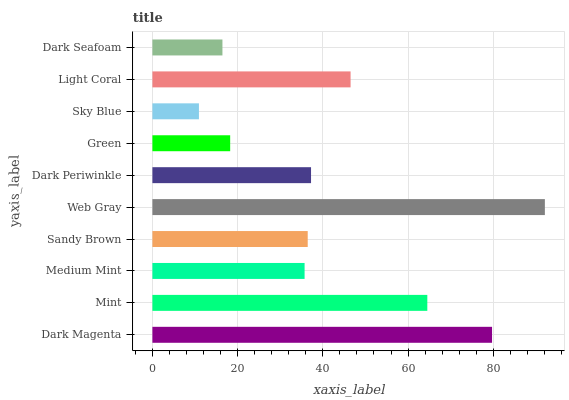Is Sky Blue the minimum?
Answer yes or no. Yes. Is Web Gray the maximum?
Answer yes or no. Yes. Is Mint the minimum?
Answer yes or no. No. Is Mint the maximum?
Answer yes or no. No. Is Dark Magenta greater than Mint?
Answer yes or no. Yes. Is Mint less than Dark Magenta?
Answer yes or no. Yes. Is Mint greater than Dark Magenta?
Answer yes or no. No. Is Dark Magenta less than Mint?
Answer yes or no. No. Is Dark Periwinkle the high median?
Answer yes or no. Yes. Is Sandy Brown the low median?
Answer yes or no. Yes. Is Mint the high median?
Answer yes or no. No. Is Web Gray the low median?
Answer yes or no. No. 